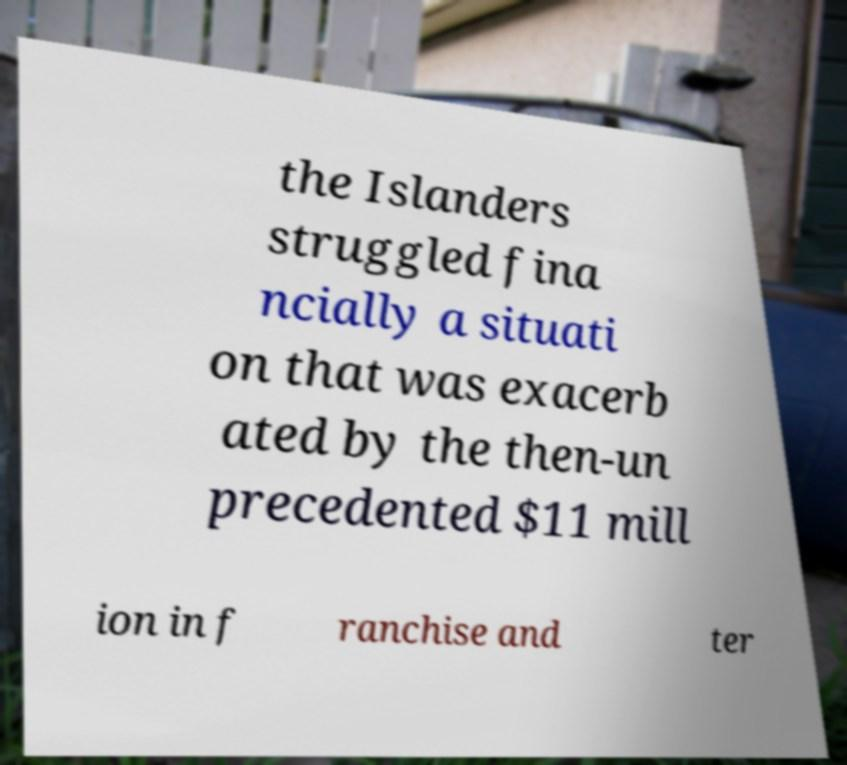For documentation purposes, I need the text within this image transcribed. Could you provide that? the Islanders struggled fina ncially a situati on that was exacerb ated by the then-un precedented $11 mill ion in f ranchise and ter 